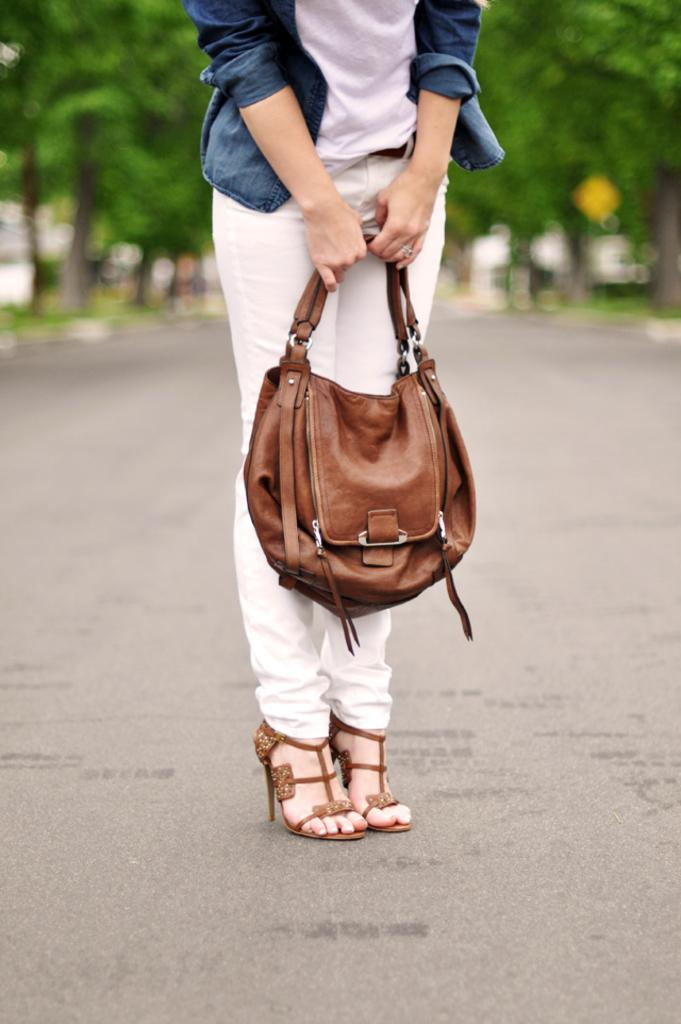What type of natural elements can be seen in the image? There are trees in the image. Can you describe the person in the image? There is a woman in the image. What is the woman holding in the image? The woman is holding a handbag. What letter is the woman trying to discover in the image? There is no indication in the image that the woman is trying to discover a letter, so it cannot be determined from the picture. 